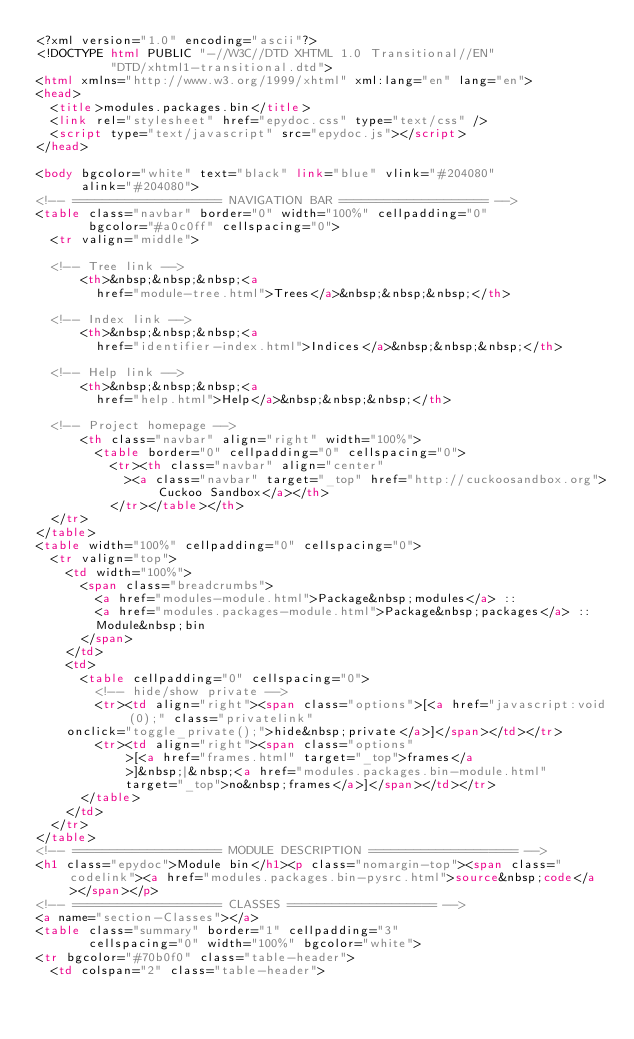<code> <loc_0><loc_0><loc_500><loc_500><_HTML_><?xml version="1.0" encoding="ascii"?>
<!DOCTYPE html PUBLIC "-//W3C//DTD XHTML 1.0 Transitional//EN"
          "DTD/xhtml1-transitional.dtd">
<html xmlns="http://www.w3.org/1999/xhtml" xml:lang="en" lang="en">
<head>
  <title>modules.packages.bin</title>
  <link rel="stylesheet" href="epydoc.css" type="text/css" />
  <script type="text/javascript" src="epydoc.js"></script>
</head>

<body bgcolor="white" text="black" link="blue" vlink="#204080"
      alink="#204080">
<!-- ==================== NAVIGATION BAR ==================== -->
<table class="navbar" border="0" width="100%" cellpadding="0"
       bgcolor="#a0c0ff" cellspacing="0">
  <tr valign="middle">

  <!-- Tree link -->
      <th>&nbsp;&nbsp;&nbsp;<a
        href="module-tree.html">Trees</a>&nbsp;&nbsp;&nbsp;</th>

  <!-- Index link -->
      <th>&nbsp;&nbsp;&nbsp;<a
        href="identifier-index.html">Indices</a>&nbsp;&nbsp;&nbsp;</th>

  <!-- Help link -->
      <th>&nbsp;&nbsp;&nbsp;<a
        href="help.html">Help</a>&nbsp;&nbsp;&nbsp;</th>

  <!-- Project homepage -->
      <th class="navbar" align="right" width="100%">
        <table border="0" cellpadding="0" cellspacing="0">
          <tr><th class="navbar" align="center"
            ><a class="navbar" target="_top" href="http://cuckoosandbox.org">Cuckoo Sandbox</a></th>
          </tr></table></th>
  </tr>
</table>
<table width="100%" cellpadding="0" cellspacing="0">
  <tr valign="top">
    <td width="100%">
      <span class="breadcrumbs">
        <a href="modules-module.html">Package&nbsp;modules</a> ::
        <a href="modules.packages-module.html">Package&nbsp;packages</a> ::
        Module&nbsp;bin
      </span>
    </td>
    <td>
      <table cellpadding="0" cellspacing="0">
        <!-- hide/show private -->
        <tr><td align="right"><span class="options">[<a href="javascript:void(0);" class="privatelink"
    onclick="toggle_private();">hide&nbsp;private</a>]</span></td></tr>
        <tr><td align="right"><span class="options"
            >[<a href="frames.html" target="_top">frames</a
            >]&nbsp;|&nbsp;<a href="modules.packages.bin-module.html"
            target="_top">no&nbsp;frames</a>]</span></td></tr>
      </table>
    </td>
  </tr>
</table>
<!-- ==================== MODULE DESCRIPTION ==================== -->
<h1 class="epydoc">Module bin</h1><p class="nomargin-top"><span class="codelink"><a href="modules.packages.bin-pysrc.html">source&nbsp;code</a></span></p>
<!-- ==================== CLASSES ==================== -->
<a name="section-Classes"></a>
<table class="summary" border="1" cellpadding="3"
       cellspacing="0" width="100%" bgcolor="white">
<tr bgcolor="#70b0f0" class="table-header">
  <td colspan="2" class="table-header"></code> 